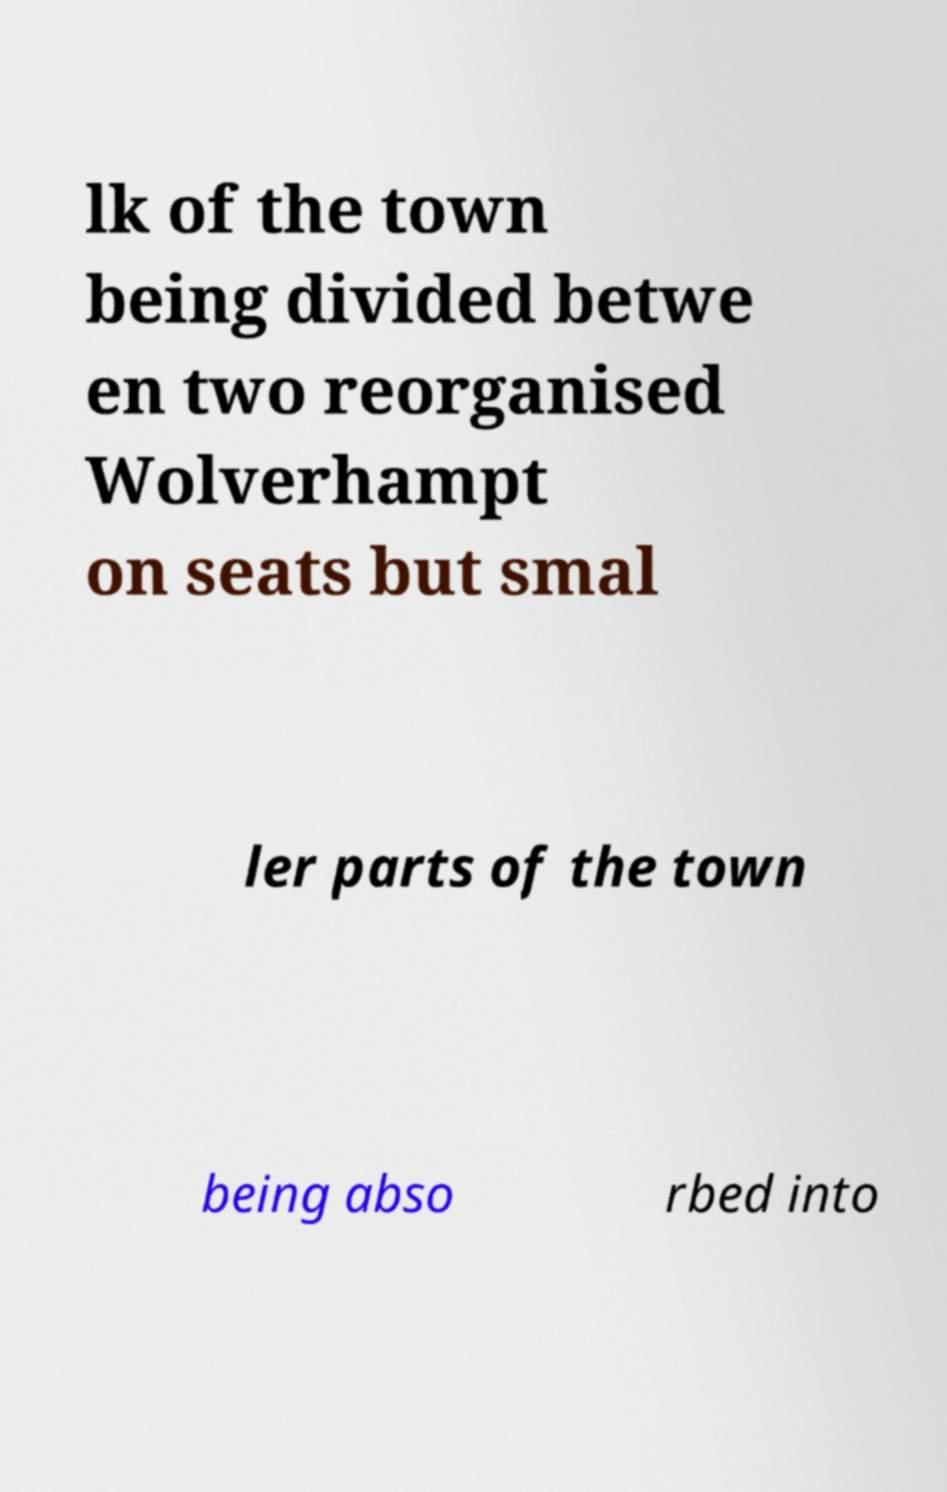For documentation purposes, I need the text within this image transcribed. Could you provide that? lk of the town being divided betwe en two reorganised Wolverhampt on seats but smal ler parts of the town being abso rbed into 